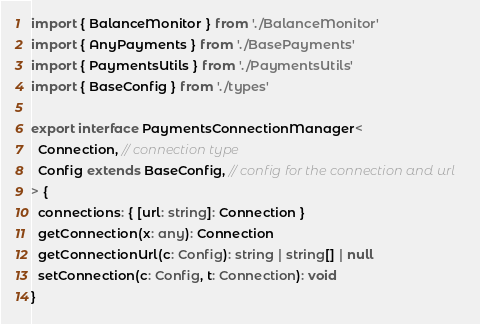<code> <loc_0><loc_0><loc_500><loc_500><_TypeScript_>import { BalanceMonitor } from './BalanceMonitor'
import { AnyPayments } from './BasePayments'
import { PaymentsUtils } from './PaymentsUtils'
import { BaseConfig } from './types'

export interface PaymentsConnectionManager<
  Connection, // connection type
  Config extends BaseConfig, // config for the connection and url
> {
  connections: { [url: string]: Connection }
  getConnection(x: any): Connection
  getConnectionUrl(c: Config): string | string[] | null
  setConnection(c: Config, t: Connection): void
}
</code> 